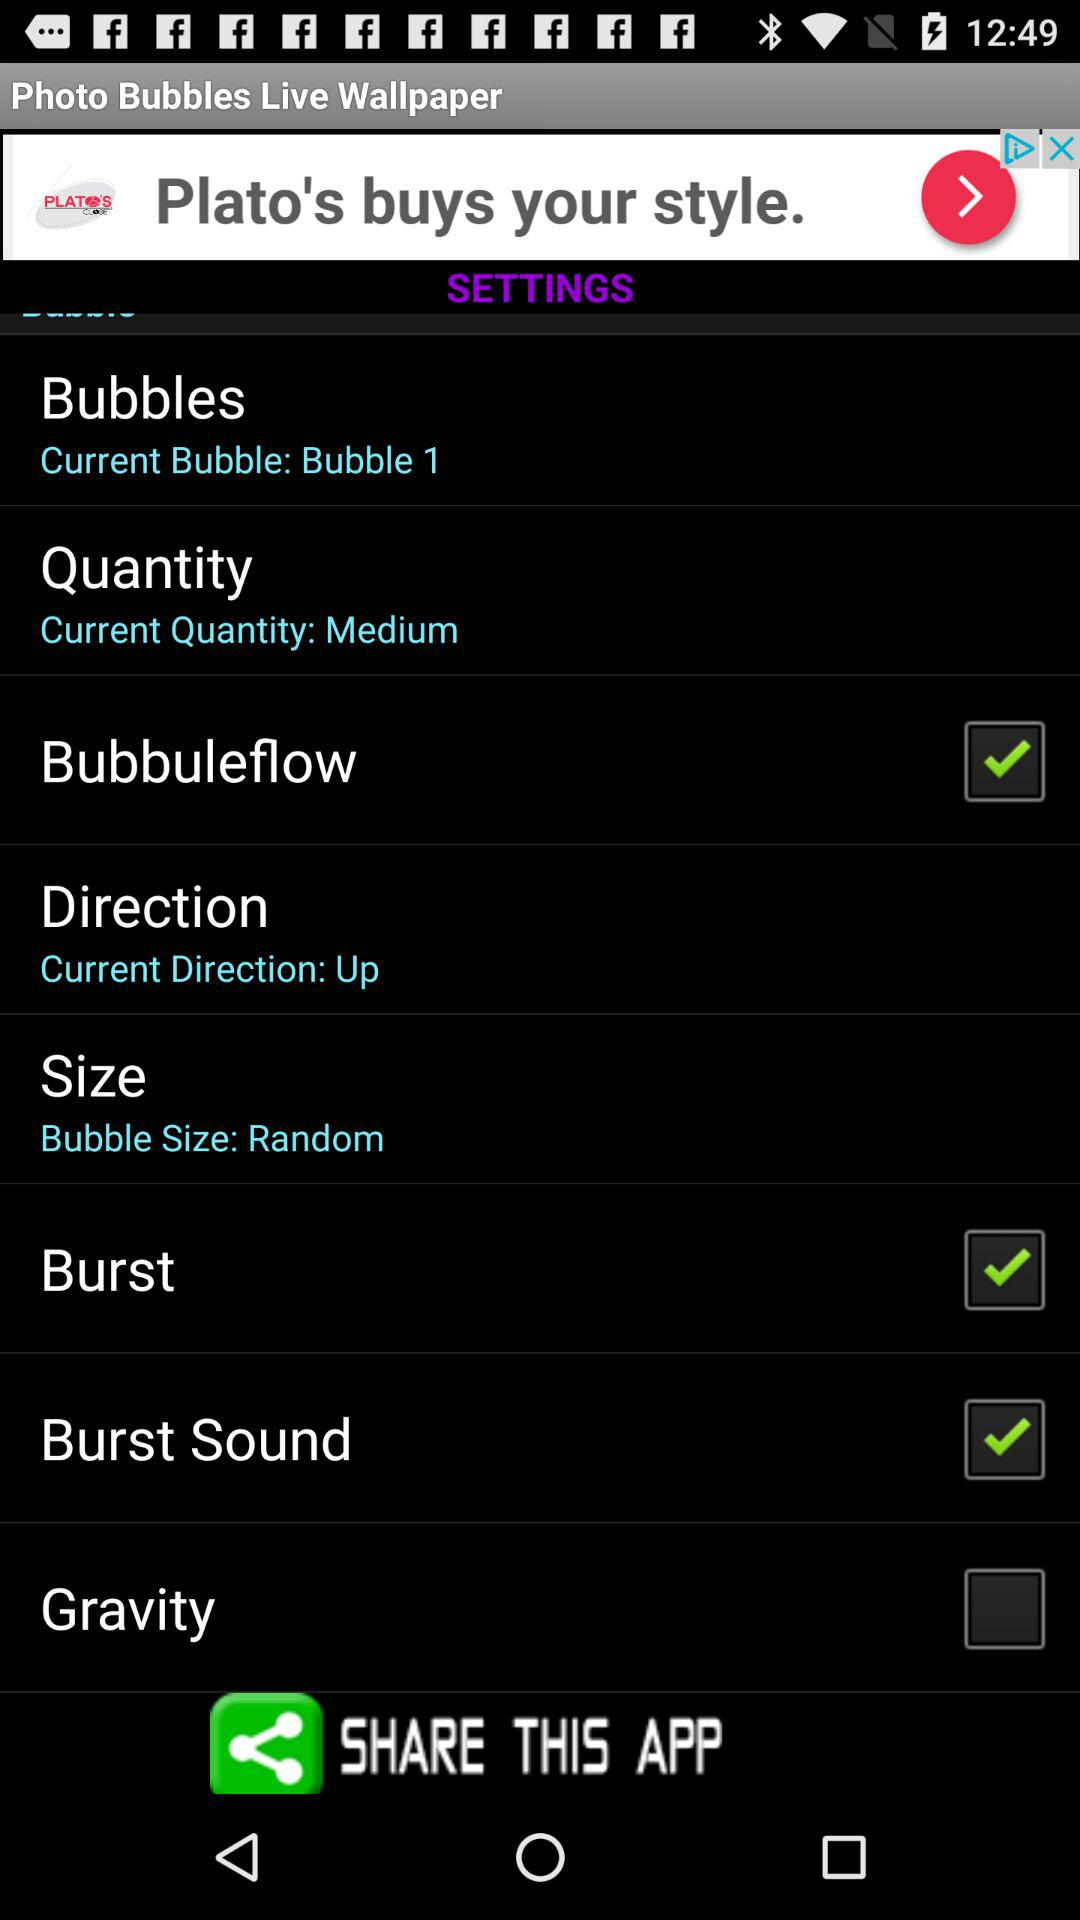What is the setting for "Bubbuleflow"? The setting for "Bubbuleflow" is "on". 